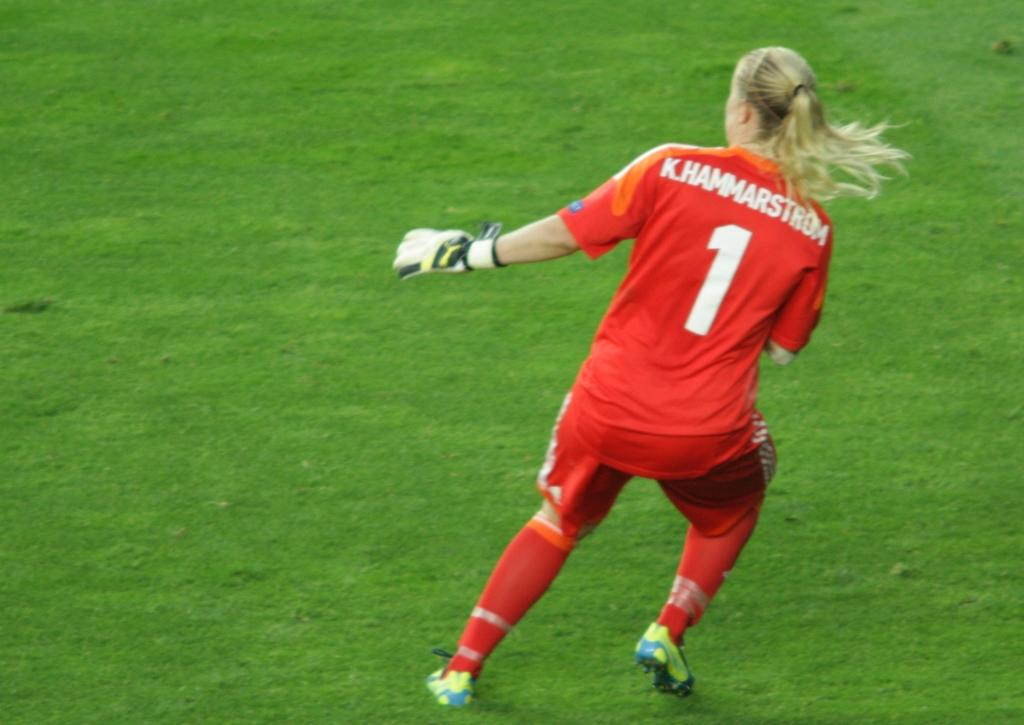<image>
Share a concise interpretation of the image provided. A female soccer player in a red uniform that says K. Hammarstrom is going for the ball. 